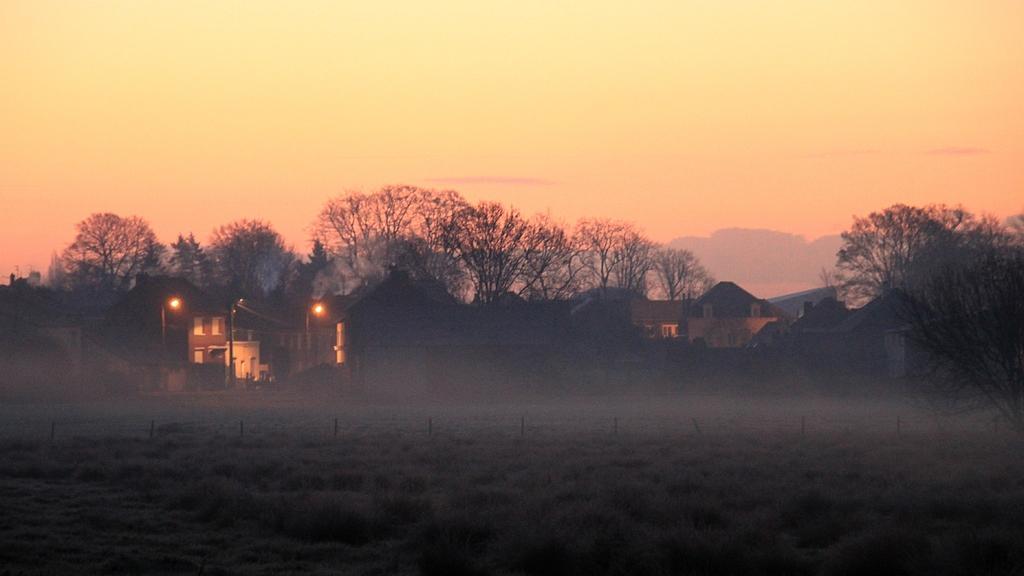In one or two sentences, can you explain what this image depicts? Here, there are some green color plants, there are some homes, there are some trees, at the top there is a sky. 